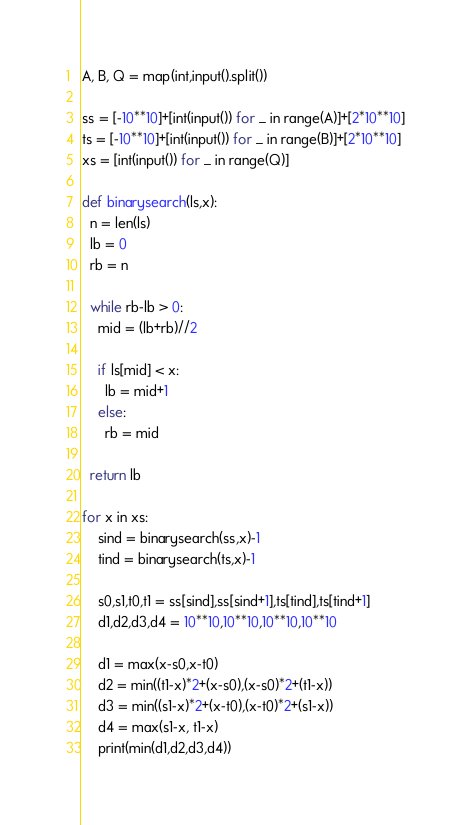<code> <loc_0><loc_0><loc_500><loc_500><_Python_>A, B, Q = map(int,input().split())

ss = [-10**10]+[int(input()) for _ in range(A)]+[2*10**10]
ts = [-10**10]+[int(input()) for _ in range(B)]+[2*10**10]
xs = [int(input()) for _ in range(Q)]

def binarysearch(ls,x):
  n = len(ls)
  lb = 0
  rb = n

  while rb-lb > 0:
    mid = (lb+rb)//2

    if ls[mid] < x:
      lb = mid+1
    else:
      rb = mid

  return lb

for x in xs:
    sind = binarysearch(ss,x)-1
    tind = binarysearch(ts,x)-1

    s0,s1,t0,t1 = ss[sind],ss[sind+1],ts[tind],ts[tind+1]
    d1,d2,d3,d4 = 10**10,10**10,10**10,10**10

    d1 = max(x-s0,x-t0)
    d2 = min((t1-x)*2+(x-s0),(x-s0)*2+(t1-x))
    d3 = min((s1-x)*2+(x-t0),(x-t0)*2+(s1-x))
    d4 = max(s1-x, t1-x)
    print(min(d1,d2,d3,d4))
</code> 